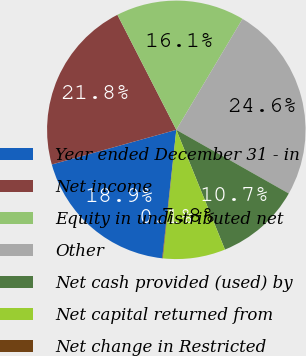Convert chart to OTSL. <chart><loc_0><loc_0><loc_500><loc_500><pie_chart><fcel>Year ended December 31 - in<fcel>Net income<fcel>Equity in undistributed net<fcel>Other<fcel>Net cash provided (used) by<fcel>Net capital returned from<fcel>Net change in Restricted<nl><fcel>18.94%<fcel>21.79%<fcel>16.1%<fcel>24.63%<fcel>10.66%<fcel>7.81%<fcel>0.07%<nl></chart> 